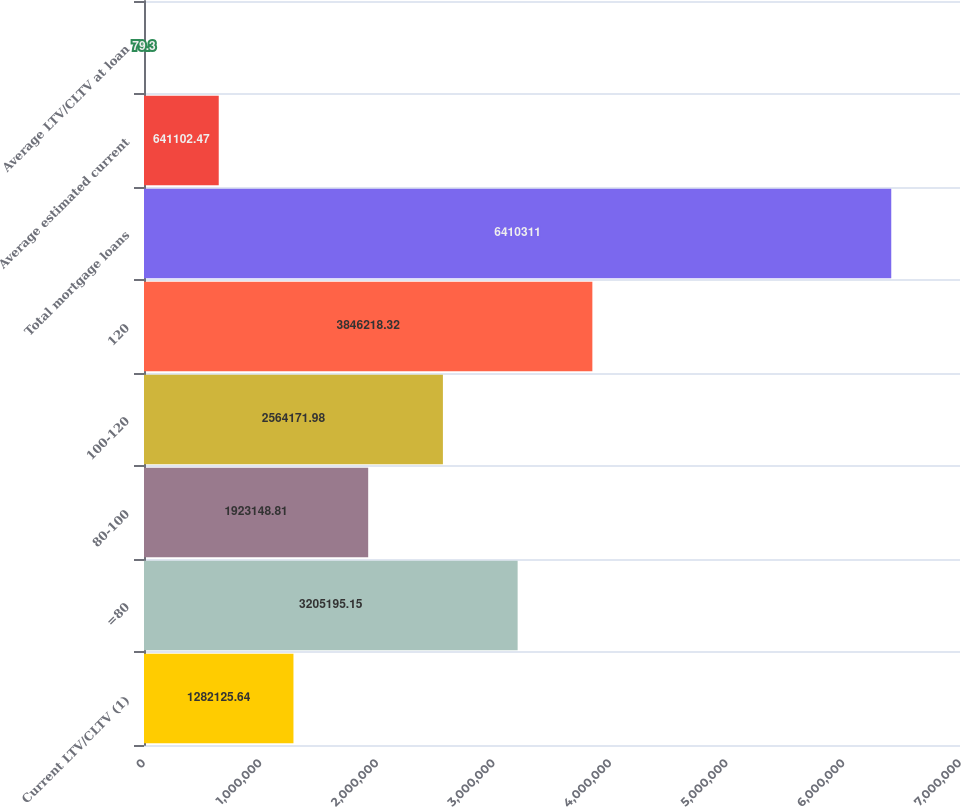Convert chart to OTSL. <chart><loc_0><loc_0><loc_500><loc_500><bar_chart><fcel>Current LTV/CLTV (1)<fcel>=80<fcel>80-100<fcel>100-120<fcel>120<fcel>Total mortgage loans<fcel>Average estimated current<fcel>Average LTV/CLTV at loan<nl><fcel>1.28213e+06<fcel>3.2052e+06<fcel>1.92315e+06<fcel>2.56417e+06<fcel>3.84622e+06<fcel>6.41031e+06<fcel>641102<fcel>79.3<nl></chart> 